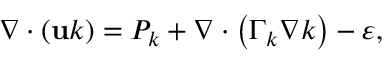Convert formula to latex. <formula><loc_0><loc_0><loc_500><loc_500>\nabla \cdot \left ( u k \right ) = P _ { k } + \nabla \cdot \left ( \Gamma _ { k } \nabla k \right ) - \varepsilon ,</formula> 